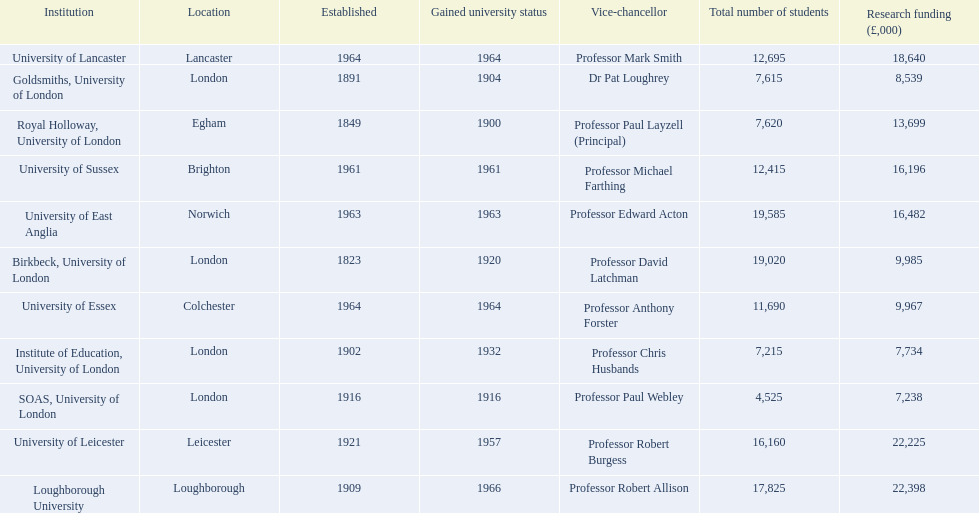What is the most recent institution to gain university status? Loughborough University. 